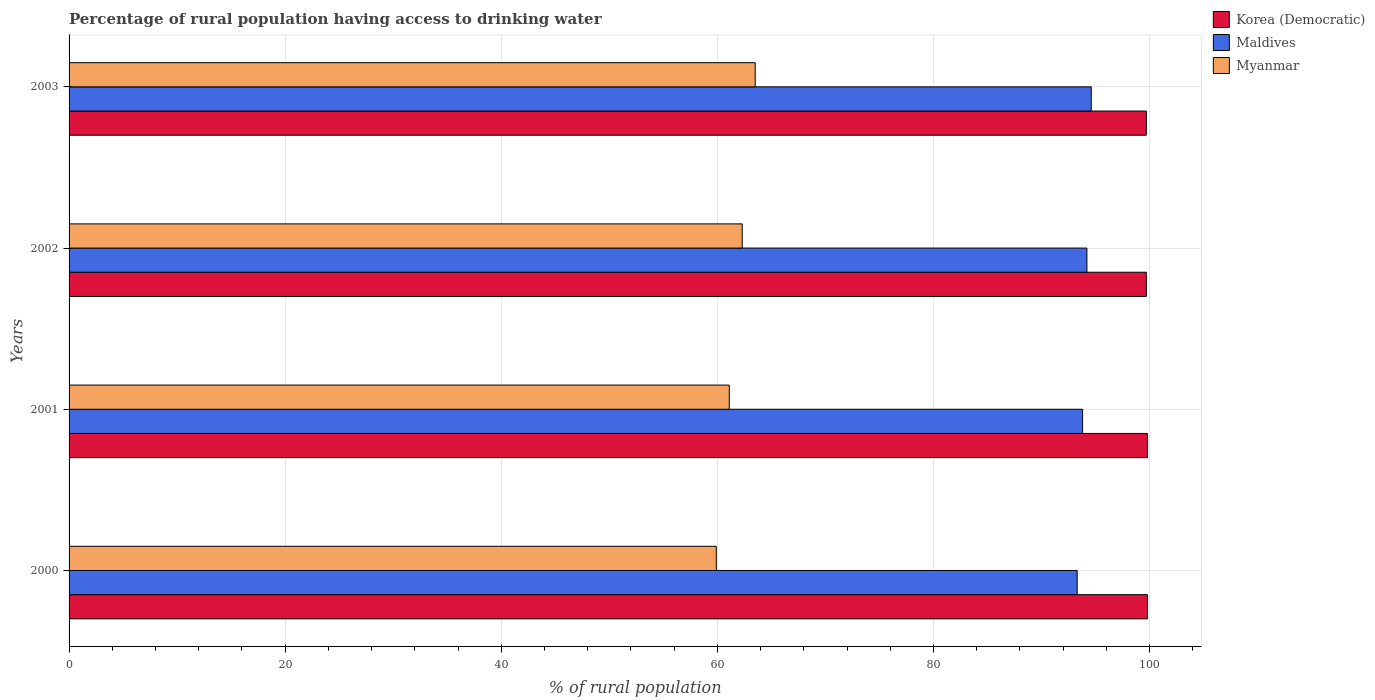How many groups of bars are there?
Your response must be concise. 4. Are the number of bars on each tick of the Y-axis equal?
Give a very brief answer. Yes. How many bars are there on the 1st tick from the top?
Give a very brief answer. 3. How many bars are there on the 1st tick from the bottom?
Your answer should be compact. 3. What is the label of the 3rd group of bars from the top?
Your answer should be very brief. 2001. What is the percentage of rural population having access to drinking water in Maldives in 2000?
Ensure brevity in your answer.  93.3. Across all years, what is the maximum percentage of rural population having access to drinking water in Myanmar?
Provide a short and direct response. 63.5. Across all years, what is the minimum percentage of rural population having access to drinking water in Maldives?
Ensure brevity in your answer.  93.3. In which year was the percentage of rural population having access to drinking water in Maldives minimum?
Make the answer very short. 2000. What is the total percentage of rural population having access to drinking water in Myanmar in the graph?
Keep it short and to the point. 246.8. What is the difference between the percentage of rural population having access to drinking water in Korea (Democratic) in 2000 and that in 2001?
Offer a terse response. 0. What is the difference between the percentage of rural population having access to drinking water in Korea (Democratic) in 2001 and the percentage of rural population having access to drinking water in Myanmar in 2003?
Your response must be concise. 36.3. What is the average percentage of rural population having access to drinking water in Korea (Democratic) per year?
Give a very brief answer. 99.75. In how many years, is the percentage of rural population having access to drinking water in Maldives greater than 20 %?
Provide a short and direct response. 4. What is the ratio of the percentage of rural population having access to drinking water in Maldives in 2000 to that in 2001?
Keep it short and to the point. 0.99. Is the percentage of rural population having access to drinking water in Korea (Democratic) in 2002 less than that in 2003?
Make the answer very short. No. What is the difference between the highest and the second highest percentage of rural population having access to drinking water in Korea (Democratic)?
Your response must be concise. 0. What is the difference between the highest and the lowest percentage of rural population having access to drinking water in Korea (Democratic)?
Your response must be concise. 0.1. In how many years, is the percentage of rural population having access to drinking water in Maldives greater than the average percentage of rural population having access to drinking water in Maldives taken over all years?
Keep it short and to the point. 2. What does the 1st bar from the top in 2001 represents?
Ensure brevity in your answer.  Myanmar. What does the 2nd bar from the bottom in 2002 represents?
Offer a very short reply. Maldives. Are the values on the major ticks of X-axis written in scientific E-notation?
Ensure brevity in your answer.  No. Does the graph contain any zero values?
Your response must be concise. No. Does the graph contain grids?
Ensure brevity in your answer.  Yes. How many legend labels are there?
Provide a short and direct response. 3. How are the legend labels stacked?
Ensure brevity in your answer.  Vertical. What is the title of the graph?
Make the answer very short. Percentage of rural population having access to drinking water. What is the label or title of the X-axis?
Your response must be concise. % of rural population. What is the label or title of the Y-axis?
Your answer should be compact. Years. What is the % of rural population in Korea (Democratic) in 2000?
Make the answer very short. 99.8. What is the % of rural population of Maldives in 2000?
Ensure brevity in your answer.  93.3. What is the % of rural population of Myanmar in 2000?
Ensure brevity in your answer.  59.9. What is the % of rural population of Korea (Democratic) in 2001?
Offer a very short reply. 99.8. What is the % of rural population of Maldives in 2001?
Your answer should be very brief. 93.8. What is the % of rural population in Myanmar in 2001?
Make the answer very short. 61.1. What is the % of rural population of Korea (Democratic) in 2002?
Your answer should be compact. 99.7. What is the % of rural population in Maldives in 2002?
Ensure brevity in your answer.  94.2. What is the % of rural population in Myanmar in 2002?
Offer a terse response. 62.3. What is the % of rural population in Korea (Democratic) in 2003?
Ensure brevity in your answer.  99.7. What is the % of rural population in Maldives in 2003?
Your answer should be very brief. 94.6. What is the % of rural population of Myanmar in 2003?
Ensure brevity in your answer.  63.5. Across all years, what is the maximum % of rural population in Korea (Democratic)?
Make the answer very short. 99.8. Across all years, what is the maximum % of rural population in Maldives?
Provide a short and direct response. 94.6. Across all years, what is the maximum % of rural population in Myanmar?
Your response must be concise. 63.5. Across all years, what is the minimum % of rural population in Korea (Democratic)?
Offer a very short reply. 99.7. Across all years, what is the minimum % of rural population in Maldives?
Your answer should be very brief. 93.3. Across all years, what is the minimum % of rural population in Myanmar?
Ensure brevity in your answer.  59.9. What is the total % of rural population of Korea (Democratic) in the graph?
Keep it short and to the point. 399. What is the total % of rural population in Maldives in the graph?
Your answer should be compact. 375.9. What is the total % of rural population in Myanmar in the graph?
Provide a succinct answer. 246.8. What is the difference between the % of rural population in Korea (Democratic) in 2000 and that in 2001?
Provide a short and direct response. 0. What is the difference between the % of rural population in Maldives in 2000 and that in 2002?
Ensure brevity in your answer.  -0.9. What is the difference between the % of rural population of Maldives in 2000 and that in 2003?
Your answer should be compact. -1.3. What is the difference between the % of rural population in Myanmar in 2000 and that in 2003?
Provide a short and direct response. -3.6. What is the difference between the % of rural population in Myanmar in 2001 and that in 2002?
Offer a terse response. -1.2. What is the difference between the % of rural population of Korea (Democratic) in 2001 and that in 2003?
Keep it short and to the point. 0.1. What is the difference between the % of rural population in Myanmar in 2001 and that in 2003?
Provide a short and direct response. -2.4. What is the difference between the % of rural population of Korea (Democratic) in 2002 and that in 2003?
Offer a terse response. 0. What is the difference between the % of rural population in Korea (Democratic) in 2000 and the % of rural population in Maldives in 2001?
Give a very brief answer. 6. What is the difference between the % of rural population in Korea (Democratic) in 2000 and the % of rural population in Myanmar in 2001?
Your answer should be compact. 38.7. What is the difference between the % of rural population in Maldives in 2000 and the % of rural population in Myanmar in 2001?
Keep it short and to the point. 32.2. What is the difference between the % of rural population of Korea (Democratic) in 2000 and the % of rural population of Myanmar in 2002?
Offer a very short reply. 37.5. What is the difference between the % of rural population of Maldives in 2000 and the % of rural population of Myanmar in 2002?
Offer a terse response. 31. What is the difference between the % of rural population in Korea (Democratic) in 2000 and the % of rural population in Myanmar in 2003?
Make the answer very short. 36.3. What is the difference between the % of rural population of Maldives in 2000 and the % of rural population of Myanmar in 2003?
Offer a very short reply. 29.8. What is the difference between the % of rural population in Korea (Democratic) in 2001 and the % of rural population in Myanmar in 2002?
Make the answer very short. 37.5. What is the difference between the % of rural population in Maldives in 2001 and the % of rural population in Myanmar in 2002?
Your answer should be compact. 31.5. What is the difference between the % of rural population of Korea (Democratic) in 2001 and the % of rural population of Maldives in 2003?
Offer a terse response. 5.2. What is the difference between the % of rural population of Korea (Democratic) in 2001 and the % of rural population of Myanmar in 2003?
Your response must be concise. 36.3. What is the difference between the % of rural population of Maldives in 2001 and the % of rural population of Myanmar in 2003?
Offer a very short reply. 30.3. What is the difference between the % of rural population of Korea (Democratic) in 2002 and the % of rural population of Maldives in 2003?
Give a very brief answer. 5.1. What is the difference between the % of rural population of Korea (Democratic) in 2002 and the % of rural population of Myanmar in 2003?
Give a very brief answer. 36.2. What is the difference between the % of rural population of Maldives in 2002 and the % of rural population of Myanmar in 2003?
Provide a short and direct response. 30.7. What is the average % of rural population of Korea (Democratic) per year?
Provide a short and direct response. 99.75. What is the average % of rural population of Maldives per year?
Make the answer very short. 93.97. What is the average % of rural population in Myanmar per year?
Make the answer very short. 61.7. In the year 2000, what is the difference between the % of rural population in Korea (Democratic) and % of rural population in Myanmar?
Make the answer very short. 39.9. In the year 2000, what is the difference between the % of rural population of Maldives and % of rural population of Myanmar?
Offer a very short reply. 33.4. In the year 2001, what is the difference between the % of rural population of Korea (Democratic) and % of rural population of Maldives?
Ensure brevity in your answer.  6. In the year 2001, what is the difference between the % of rural population of Korea (Democratic) and % of rural population of Myanmar?
Your response must be concise. 38.7. In the year 2001, what is the difference between the % of rural population in Maldives and % of rural population in Myanmar?
Keep it short and to the point. 32.7. In the year 2002, what is the difference between the % of rural population of Korea (Democratic) and % of rural population of Maldives?
Your response must be concise. 5.5. In the year 2002, what is the difference between the % of rural population in Korea (Democratic) and % of rural population in Myanmar?
Offer a very short reply. 37.4. In the year 2002, what is the difference between the % of rural population in Maldives and % of rural population in Myanmar?
Your answer should be compact. 31.9. In the year 2003, what is the difference between the % of rural population in Korea (Democratic) and % of rural population in Maldives?
Provide a short and direct response. 5.1. In the year 2003, what is the difference between the % of rural population in Korea (Democratic) and % of rural population in Myanmar?
Keep it short and to the point. 36.2. In the year 2003, what is the difference between the % of rural population of Maldives and % of rural population of Myanmar?
Keep it short and to the point. 31.1. What is the ratio of the % of rural population in Korea (Democratic) in 2000 to that in 2001?
Offer a very short reply. 1. What is the ratio of the % of rural population of Maldives in 2000 to that in 2001?
Offer a terse response. 0.99. What is the ratio of the % of rural population in Myanmar in 2000 to that in 2001?
Offer a terse response. 0.98. What is the ratio of the % of rural population in Myanmar in 2000 to that in 2002?
Offer a very short reply. 0.96. What is the ratio of the % of rural population of Korea (Democratic) in 2000 to that in 2003?
Offer a terse response. 1. What is the ratio of the % of rural population in Maldives in 2000 to that in 2003?
Your answer should be compact. 0.99. What is the ratio of the % of rural population of Myanmar in 2000 to that in 2003?
Your answer should be very brief. 0.94. What is the ratio of the % of rural population of Korea (Democratic) in 2001 to that in 2002?
Your response must be concise. 1. What is the ratio of the % of rural population in Maldives in 2001 to that in 2002?
Offer a terse response. 1. What is the ratio of the % of rural population in Myanmar in 2001 to that in 2002?
Your response must be concise. 0.98. What is the ratio of the % of rural population in Myanmar in 2001 to that in 2003?
Offer a terse response. 0.96. What is the ratio of the % of rural population in Myanmar in 2002 to that in 2003?
Keep it short and to the point. 0.98. What is the difference between the highest and the second highest % of rural population of Korea (Democratic)?
Offer a terse response. 0. What is the difference between the highest and the second highest % of rural population of Myanmar?
Keep it short and to the point. 1.2. What is the difference between the highest and the lowest % of rural population of Korea (Democratic)?
Provide a short and direct response. 0.1. What is the difference between the highest and the lowest % of rural population in Maldives?
Provide a succinct answer. 1.3. 